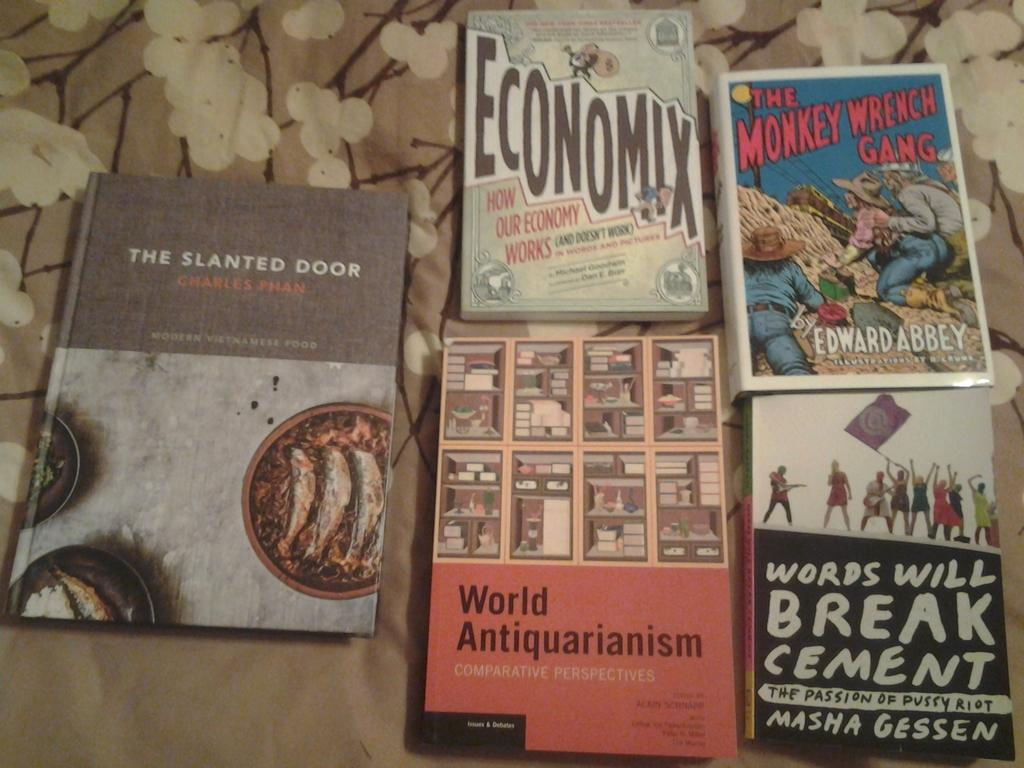<image>
Provide a brief description of the given image. Several books include a copy of The Slanted Door by Charles Phan. 